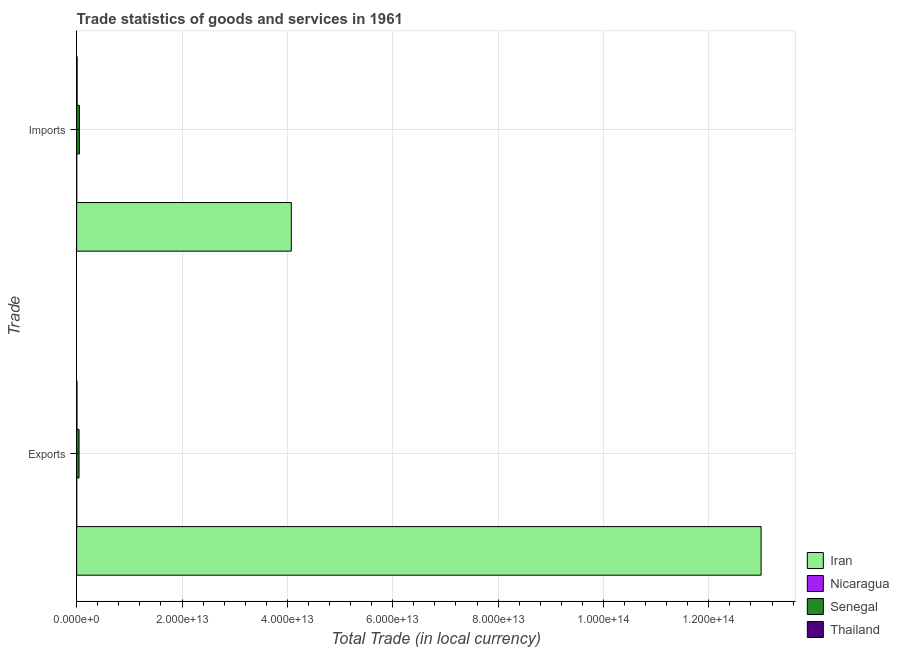How many different coloured bars are there?
Offer a very short reply. 4. Are the number of bars per tick equal to the number of legend labels?
Your response must be concise. Yes. How many bars are there on the 1st tick from the top?
Ensure brevity in your answer.  4. How many bars are there on the 1st tick from the bottom?
Ensure brevity in your answer.  4. What is the label of the 2nd group of bars from the top?
Offer a terse response. Exports. What is the export of goods and services in Thailand?
Ensure brevity in your answer.  5.97e+1. Across all countries, what is the maximum export of goods and services?
Your answer should be compact. 1.30e+14. Across all countries, what is the minimum export of goods and services?
Keep it short and to the point. 3.83e+09. In which country was the export of goods and services maximum?
Offer a very short reply. Iran. In which country was the export of goods and services minimum?
Make the answer very short. Nicaragua. What is the total export of goods and services in the graph?
Offer a terse response. 1.30e+14. What is the difference between the export of goods and services in Thailand and that in Nicaragua?
Your answer should be compact. 5.58e+1. What is the difference between the export of goods and services in Nicaragua and the imports of goods and services in Iran?
Offer a very short reply. -4.07e+13. What is the average imports of goods and services per country?
Keep it short and to the point. 1.03e+13. What is the difference between the imports of goods and services and export of goods and services in Thailand?
Give a very brief answer. 2.50e+1. What is the ratio of the imports of goods and services in Iran to that in Thailand?
Keep it short and to the point. 481.32. In how many countries, is the export of goods and services greater than the average export of goods and services taken over all countries?
Provide a short and direct response. 1. What does the 1st bar from the top in Exports represents?
Provide a succinct answer. Thailand. What does the 4th bar from the bottom in Imports represents?
Offer a very short reply. Thailand. Are all the bars in the graph horizontal?
Keep it short and to the point. Yes. What is the difference between two consecutive major ticks on the X-axis?
Your response must be concise. 2.00e+13. Does the graph contain any zero values?
Make the answer very short. No. Does the graph contain grids?
Offer a terse response. Yes. How many legend labels are there?
Offer a very short reply. 4. What is the title of the graph?
Keep it short and to the point. Trade statistics of goods and services in 1961. What is the label or title of the X-axis?
Ensure brevity in your answer.  Total Trade (in local currency). What is the label or title of the Y-axis?
Give a very brief answer. Trade. What is the Total Trade (in local currency) in Iran in Exports?
Make the answer very short. 1.30e+14. What is the Total Trade (in local currency) in Nicaragua in Exports?
Make the answer very short. 3.83e+09. What is the Total Trade (in local currency) of Senegal in Exports?
Your response must be concise. 4.52e+11. What is the Total Trade (in local currency) in Thailand in Exports?
Offer a terse response. 5.97e+1. What is the Total Trade (in local currency) in Iran in Imports?
Your answer should be very brief. 4.07e+13. What is the Total Trade (in local currency) of Nicaragua in Imports?
Provide a succinct answer. 5.92e+09. What is the Total Trade (in local currency) of Senegal in Imports?
Your answer should be compact. 5.16e+11. What is the Total Trade (in local currency) of Thailand in Imports?
Your answer should be very brief. 8.46e+1. Across all Trade, what is the maximum Total Trade (in local currency) of Iran?
Your answer should be compact. 1.30e+14. Across all Trade, what is the maximum Total Trade (in local currency) of Nicaragua?
Provide a succinct answer. 5.92e+09. Across all Trade, what is the maximum Total Trade (in local currency) of Senegal?
Keep it short and to the point. 5.16e+11. Across all Trade, what is the maximum Total Trade (in local currency) in Thailand?
Offer a terse response. 8.46e+1. Across all Trade, what is the minimum Total Trade (in local currency) in Iran?
Your response must be concise. 4.07e+13. Across all Trade, what is the minimum Total Trade (in local currency) of Nicaragua?
Make the answer very short. 3.83e+09. Across all Trade, what is the minimum Total Trade (in local currency) in Senegal?
Ensure brevity in your answer.  4.52e+11. Across all Trade, what is the minimum Total Trade (in local currency) in Thailand?
Offer a terse response. 5.97e+1. What is the total Total Trade (in local currency) of Iran in the graph?
Make the answer very short. 1.71e+14. What is the total Total Trade (in local currency) in Nicaragua in the graph?
Offer a terse response. 9.75e+09. What is the total Total Trade (in local currency) in Senegal in the graph?
Provide a succinct answer. 9.68e+11. What is the total Total Trade (in local currency) of Thailand in the graph?
Make the answer very short. 1.44e+11. What is the difference between the Total Trade (in local currency) of Iran in Exports and that in Imports?
Your answer should be compact. 8.92e+13. What is the difference between the Total Trade (in local currency) of Nicaragua in Exports and that in Imports?
Your response must be concise. -2.10e+09. What is the difference between the Total Trade (in local currency) of Senegal in Exports and that in Imports?
Your response must be concise. -6.35e+1. What is the difference between the Total Trade (in local currency) in Thailand in Exports and that in Imports?
Offer a very short reply. -2.50e+1. What is the difference between the Total Trade (in local currency) of Iran in Exports and the Total Trade (in local currency) of Nicaragua in Imports?
Offer a very short reply. 1.30e+14. What is the difference between the Total Trade (in local currency) in Iran in Exports and the Total Trade (in local currency) in Senegal in Imports?
Your response must be concise. 1.29e+14. What is the difference between the Total Trade (in local currency) of Iran in Exports and the Total Trade (in local currency) of Thailand in Imports?
Ensure brevity in your answer.  1.30e+14. What is the difference between the Total Trade (in local currency) of Nicaragua in Exports and the Total Trade (in local currency) of Senegal in Imports?
Ensure brevity in your answer.  -5.12e+11. What is the difference between the Total Trade (in local currency) in Nicaragua in Exports and the Total Trade (in local currency) in Thailand in Imports?
Your answer should be very brief. -8.08e+1. What is the difference between the Total Trade (in local currency) in Senegal in Exports and the Total Trade (in local currency) in Thailand in Imports?
Make the answer very short. 3.68e+11. What is the average Total Trade (in local currency) in Iran per Trade?
Keep it short and to the point. 8.53e+13. What is the average Total Trade (in local currency) in Nicaragua per Trade?
Your response must be concise. 4.88e+09. What is the average Total Trade (in local currency) in Senegal per Trade?
Make the answer very short. 4.84e+11. What is the average Total Trade (in local currency) of Thailand per Trade?
Keep it short and to the point. 7.21e+1. What is the difference between the Total Trade (in local currency) of Iran and Total Trade (in local currency) of Nicaragua in Exports?
Offer a terse response. 1.30e+14. What is the difference between the Total Trade (in local currency) in Iran and Total Trade (in local currency) in Senegal in Exports?
Make the answer very short. 1.29e+14. What is the difference between the Total Trade (in local currency) in Iran and Total Trade (in local currency) in Thailand in Exports?
Offer a terse response. 1.30e+14. What is the difference between the Total Trade (in local currency) of Nicaragua and Total Trade (in local currency) of Senegal in Exports?
Your answer should be very brief. -4.49e+11. What is the difference between the Total Trade (in local currency) of Nicaragua and Total Trade (in local currency) of Thailand in Exports?
Offer a terse response. -5.58e+1. What is the difference between the Total Trade (in local currency) of Senegal and Total Trade (in local currency) of Thailand in Exports?
Offer a very short reply. 3.93e+11. What is the difference between the Total Trade (in local currency) in Iran and Total Trade (in local currency) in Nicaragua in Imports?
Your response must be concise. 4.07e+13. What is the difference between the Total Trade (in local currency) in Iran and Total Trade (in local currency) in Senegal in Imports?
Offer a very short reply. 4.02e+13. What is the difference between the Total Trade (in local currency) of Iran and Total Trade (in local currency) of Thailand in Imports?
Ensure brevity in your answer.  4.07e+13. What is the difference between the Total Trade (in local currency) of Nicaragua and Total Trade (in local currency) of Senegal in Imports?
Offer a very short reply. -5.10e+11. What is the difference between the Total Trade (in local currency) in Nicaragua and Total Trade (in local currency) in Thailand in Imports?
Provide a succinct answer. -7.87e+1. What is the difference between the Total Trade (in local currency) of Senegal and Total Trade (in local currency) of Thailand in Imports?
Keep it short and to the point. 4.31e+11. What is the ratio of the Total Trade (in local currency) of Iran in Exports to that in Imports?
Offer a very short reply. 3.19. What is the ratio of the Total Trade (in local currency) in Nicaragua in Exports to that in Imports?
Give a very brief answer. 0.65. What is the ratio of the Total Trade (in local currency) of Senegal in Exports to that in Imports?
Your answer should be compact. 0.88. What is the ratio of the Total Trade (in local currency) in Thailand in Exports to that in Imports?
Your answer should be very brief. 0.7. What is the difference between the highest and the second highest Total Trade (in local currency) of Iran?
Provide a short and direct response. 8.92e+13. What is the difference between the highest and the second highest Total Trade (in local currency) of Nicaragua?
Keep it short and to the point. 2.10e+09. What is the difference between the highest and the second highest Total Trade (in local currency) of Senegal?
Offer a very short reply. 6.35e+1. What is the difference between the highest and the second highest Total Trade (in local currency) in Thailand?
Make the answer very short. 2.50e+1. What is the difference between the highest and the lowest Total Trade (in local currency) of Iran?
Make the answer very short. 8.92e+13. What is the difference between the highest and the lowest Total Trade (in local currency) of Nicaragua?
Provide a short and direct response. 2.10e+09. What is the difference between the highest and the lowest Total Trade (in local currency) in Senegal?
Make the answer very short. 6.35e+1. What is the difference between the highest and the lowest Total Trade (in local currency) in Thailand?
Offer a very short reply. 2.50e+1. 